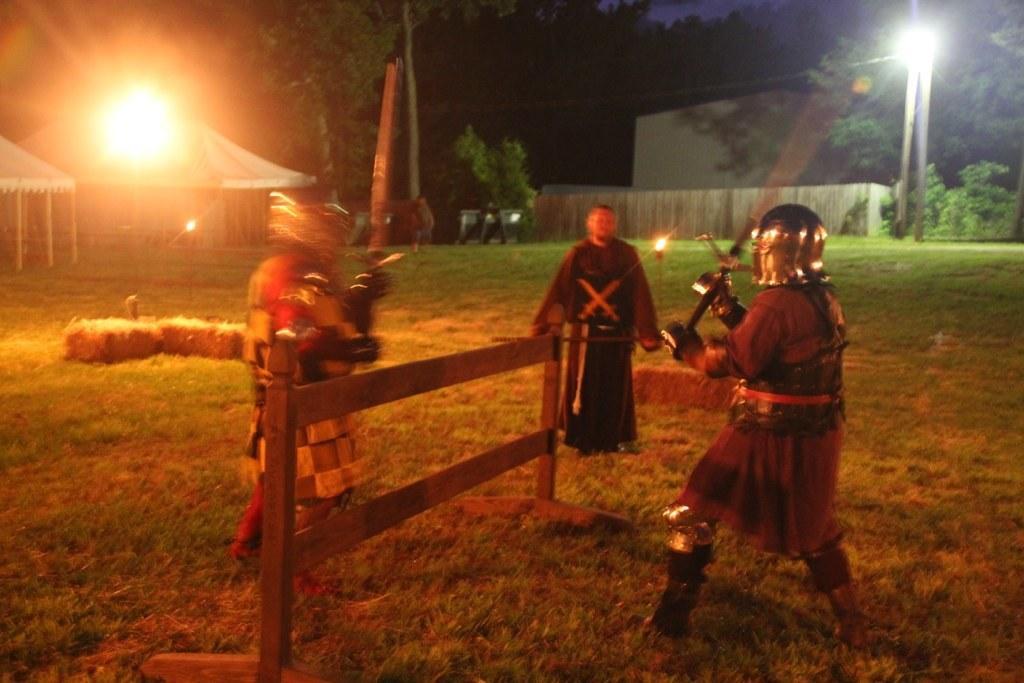How would you summarize this image in a sentence or two? In this image there are two persons standing on the ground. They are holding swords in their hands. They are wearing helmets. In between them there is a fence. Behind them there is a man standing on the ground. To the left there are tents. To the right there is a house. There is a fencing around the house. In front of the house there is a street light pole. In the background there are trees. There is grass on the ground. 